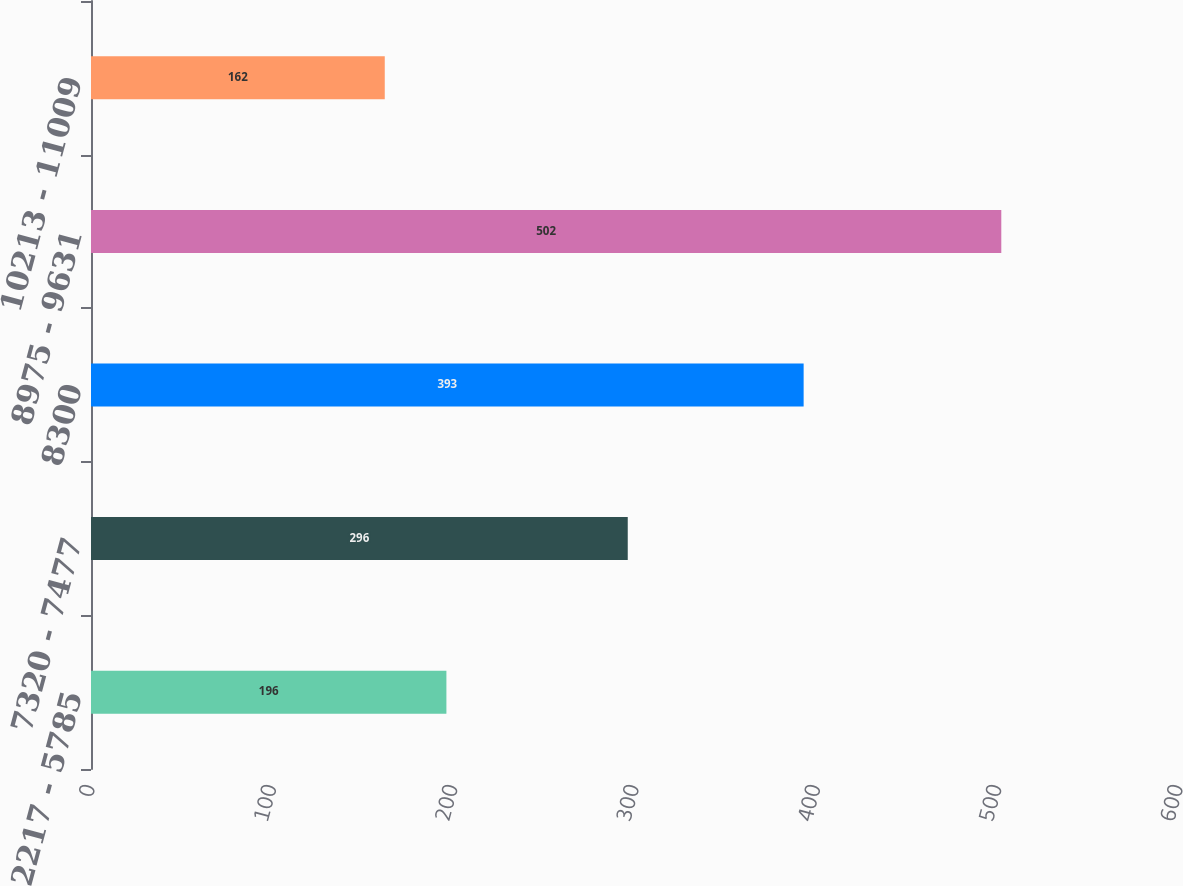Convert chart. <chart><loc_0><loc_0><loc_500><loc_500><bar_chart><fcel>2217 - 5785<fcel>7320 - 7477<fcel>8300<fcel>8975 - 9631<fcel>10213 - 11009<nl><fcel>196<fcel>296<fcel>393<fcel>502<fcel>162<nl></chart> 